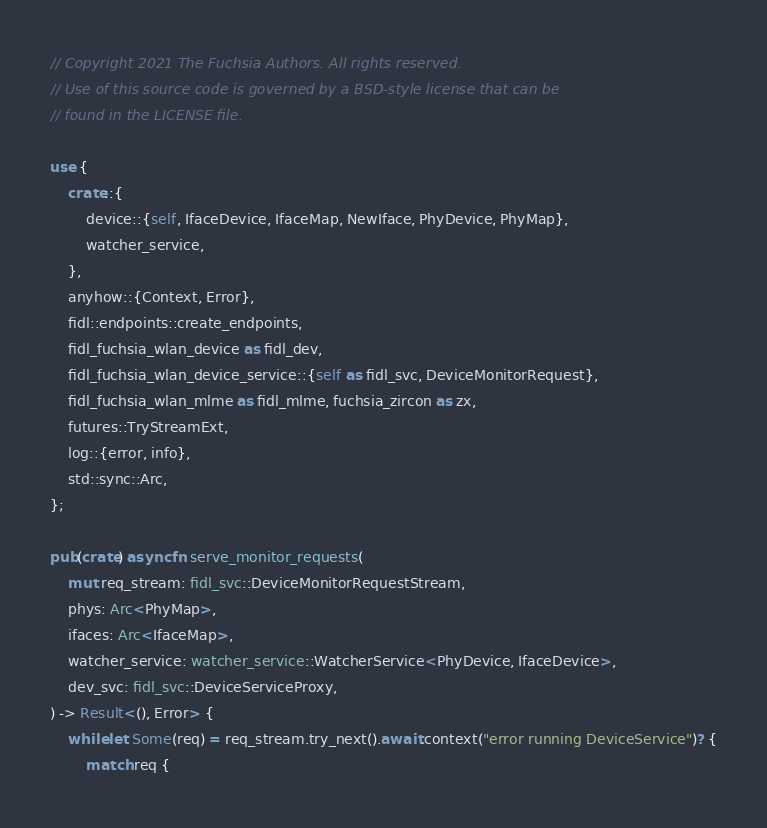<code> <loc_0><loc_0><loc_500><loc_500><_Rust_>// Copyright 2021 The Fuchsia Authors. All rights reserved.
// Use of this source code is governed by a BSD-style license that can be
// found in the LICENSE file.

use {
    crate::{
        device::{self, IfaceDevice, IfaceMap, NewIface, PhyDevice, PhyMap},
        watcher_service,
    },
    anyhow::{Context, Error},
    fidl::endpoints::create_endpoints,
    fidl_fuchsia_wlan_device as fidl_dev,
    fidl_fuchsia_wlan_device_service::{self as fidl_svc, DeviceMonitorRequest},
    fidl_fuchsia_wlan_mlme as fidl_mlme, fuchsia_zircon as zx,
    futures::TryStreamExt,
    log::{error, info},
    std::sync::Arc,
};

pub(crate) async fn serve_monitor_requests(
    mut req_stream: fidl_svc::DeviceMonitorRequestStream,
    phys: Arc<PhyMap>,
    ifaces: Arc<IfaceMap>,
    watcher_service: watcher_service::WatcherService<PhyDevice, IfaceDevice>,
    dev_svc: fidl_svc::DeviceServiceProxy,
) -> Result<(), Error> {
    while let Some(req) = req_stream.try_next().await.context("error running DeviceService")? {
        match req {</code> 